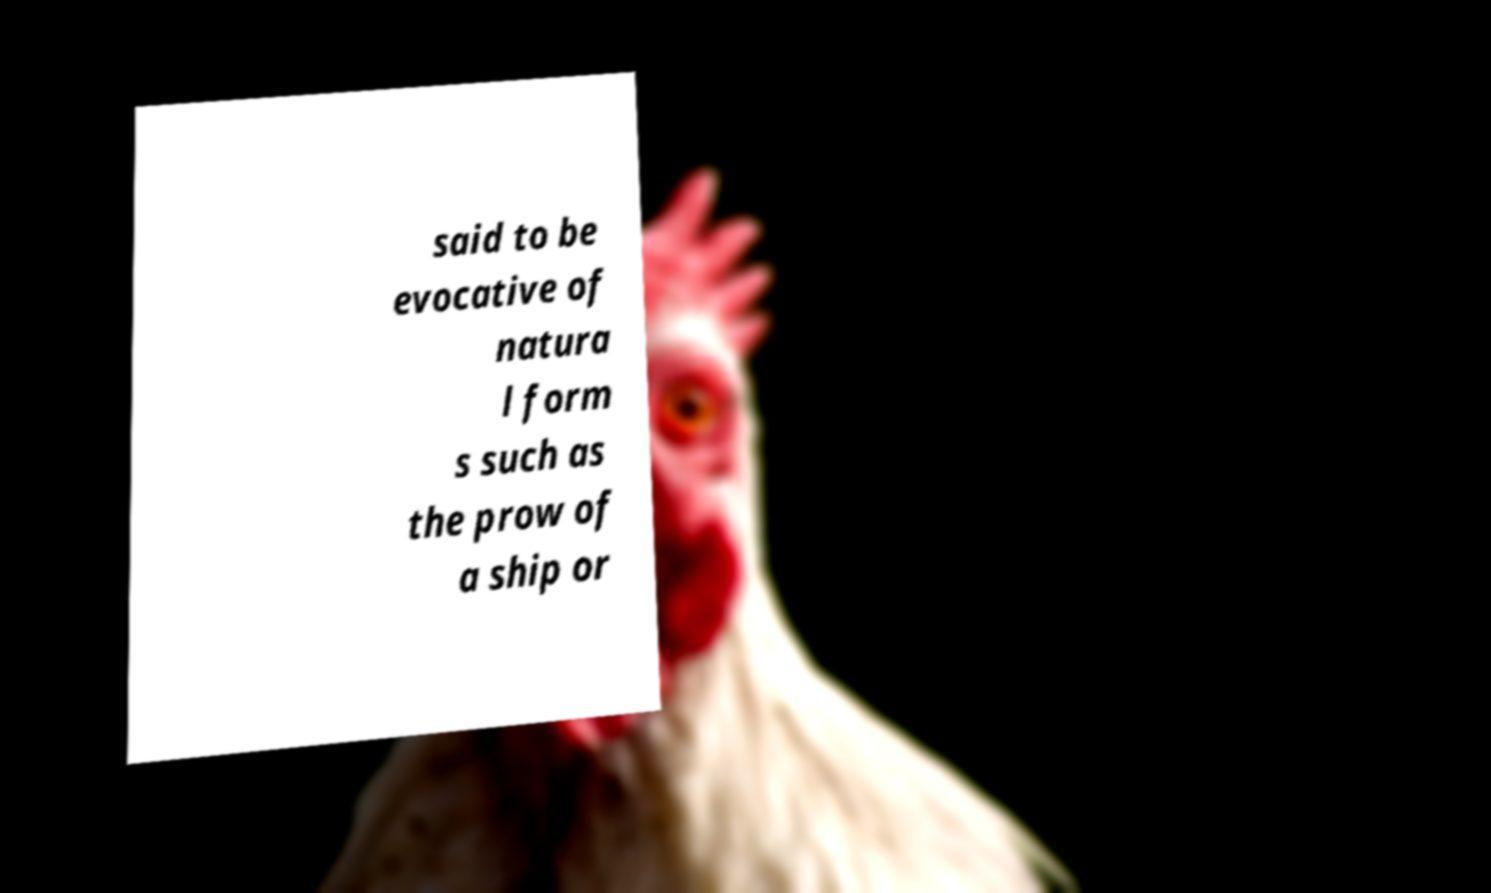Please identify and transcribe the text found in this image. said to be evocative of natura l form s such as the prow of a ship or 